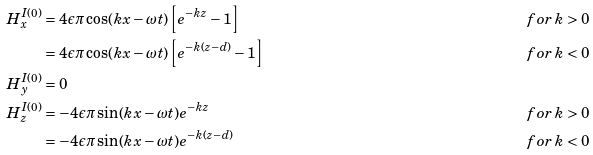Convert formula to latex. <formula><loc_0><loc_0><loc_500><loc_500>H _ { x } ^ { I ( 0 ) } & = 4 \epsilon \pi \cos ( k x - \omega t ) \left [ e ^ { - k z } - 1 \right ] \, & f o r \, k & > 0 \\ & = 4 \epsilon \pi \cos ( k x - \omega t ) \left [ e ^ { - k ( z - d ) } - 1 \right ] \, & f o r \, k & < 0 \\ H _ { y } ^ { I ( 0 ) } & = 0 \quad & \quad & \\ H _ { z } ^ { I ( 0 ) } & = - 4 \epsilon \pi \sin ( k x - \omega t ) e ^ { - k z } \, & f o r \, k & > 0 \\ & = - 4 \epsilon \pi \sin ( k x - \omega t ) e ^ { - k ( z - d ) } \, & f o r \, k & < 0</formula> 